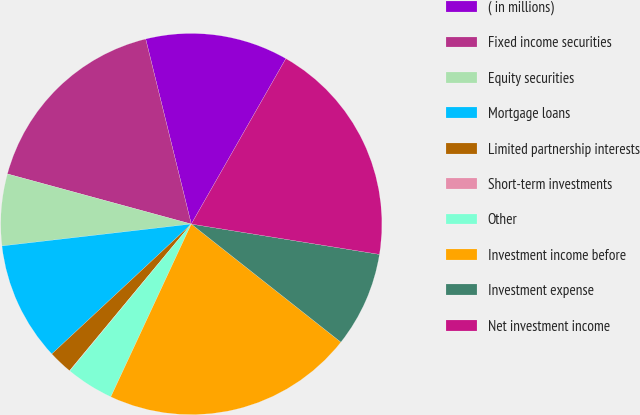Convert chart. <chart><loc_0><loc_0><loc_500><loc_500><pie_chart><fcel>( in millions)<fcel>Fixed income securities<fcel>Equity securities<fcel>Mortgage loans<fcel>Limited partnership interests<fcel>Short-term investments<fcel>Other<fcel>Investment income before<fcel>Investment expense<fcel>Net investment income<nl><fcel>12.11%<fcel>16.92%<fcel>6.07%<fcel>10.1%<fcel>2.04%<fcel>0.03%<fcel>4.06%<fcel>21.3%<fcel>8.09%<fcel>19.28%<nl></chart> 